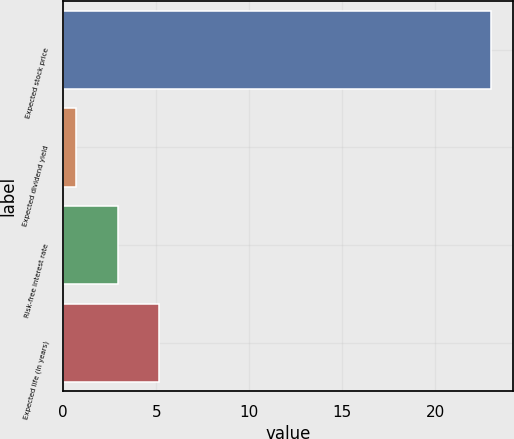<chart> <loc_0><loc_0><loc_500><loc_500><bar_chart><fcel>Expected stock price<fcel>Expected dividend yield<fcel>Risk-free interest rate<fcel>Expected life (in years)<nl><fcel>23<fcel>0.7<fcel>2.93<fcel>5.16<nl></chart> 